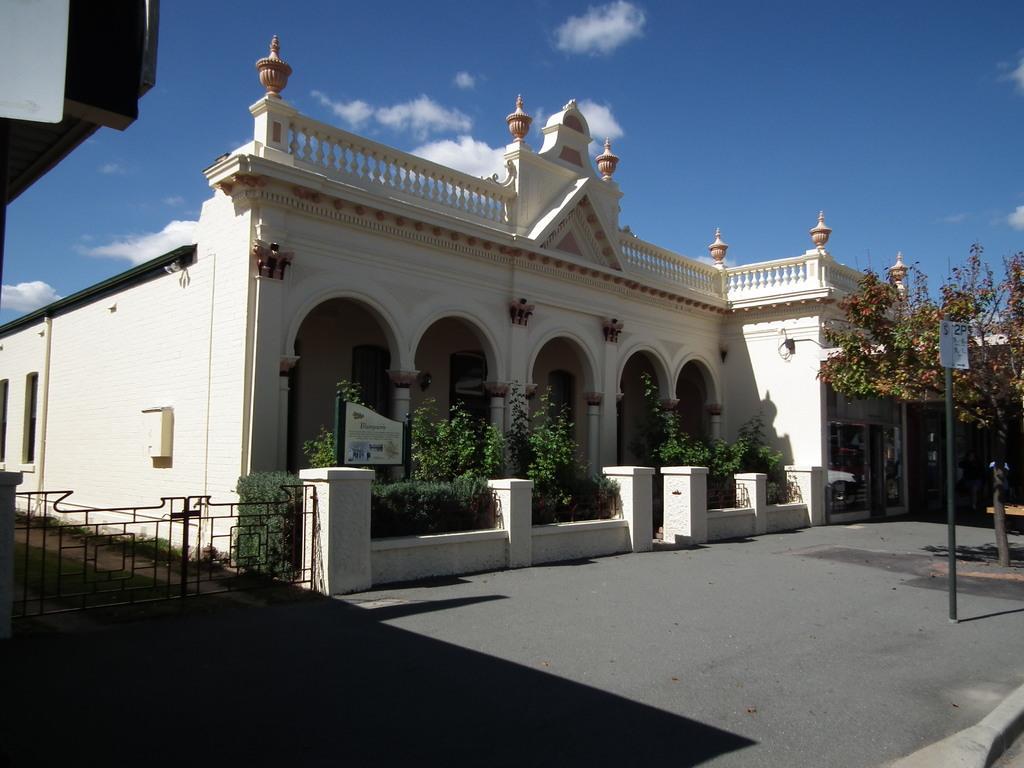Can you describe this image briefly? In this image we can see building, arches, trees, poles, pants, fence in the background. We can see the sky. 